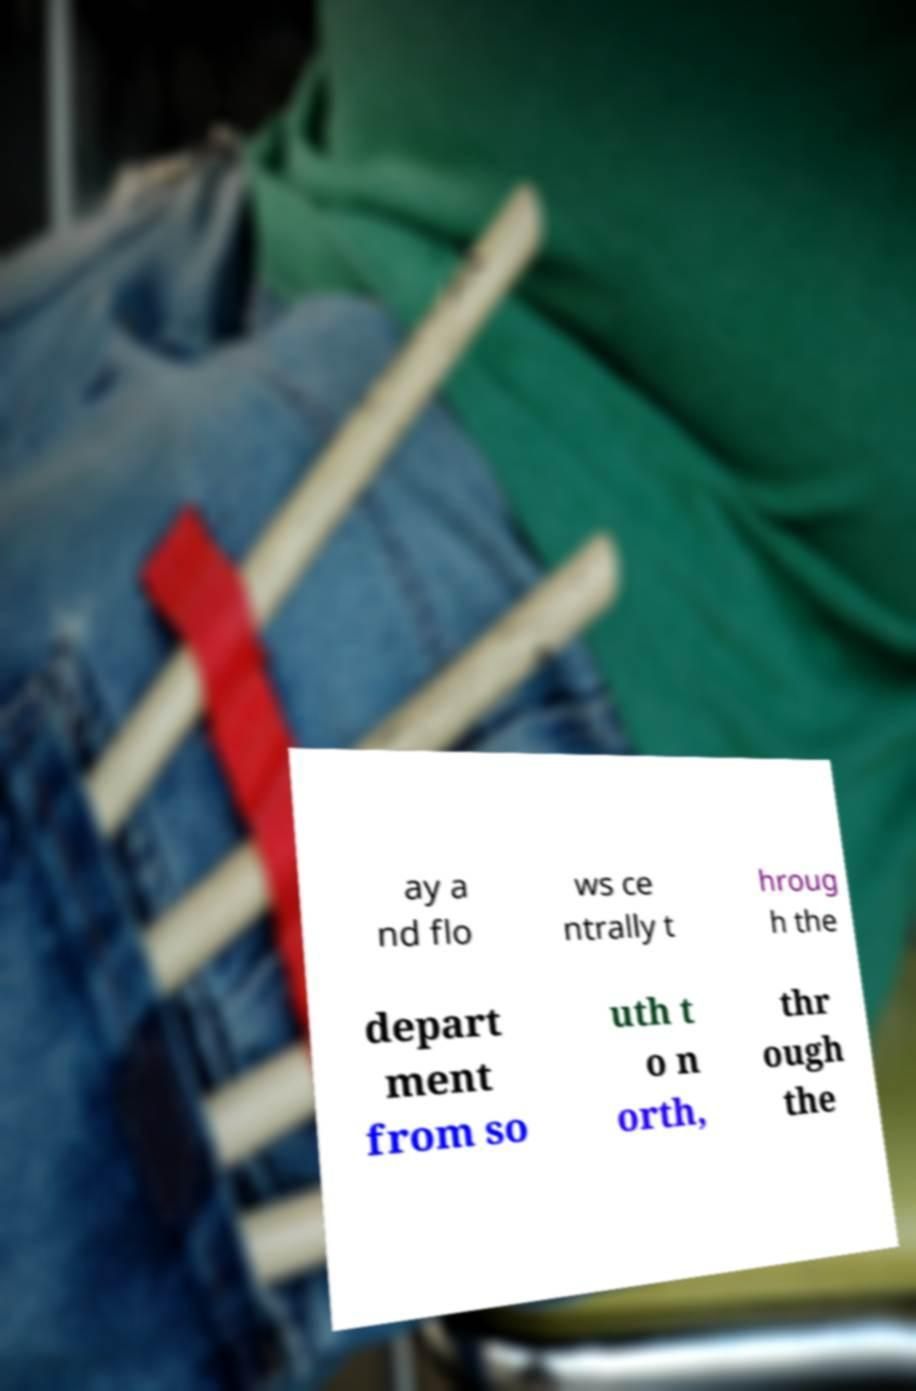Please read and relay the text visible in this image. What does it say? ay a nd flo ws ce ntrally t hroug h the depart ment from so uth t o n orth, thr ough the 